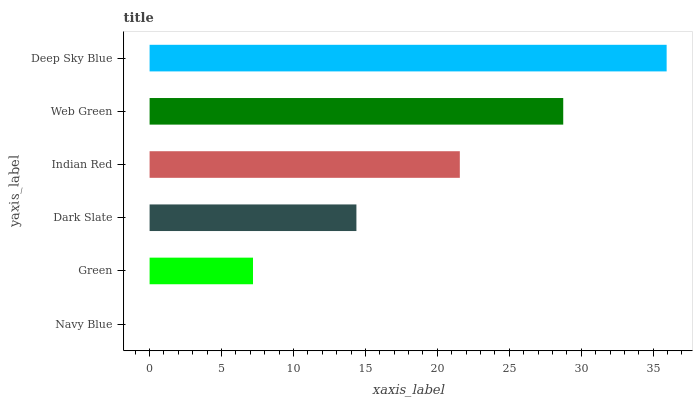Is Navy Blue the minimum?
Answer yes or no. Yes. Is Deep Sky Blue the maximum?
Answer yes or no. Yes. Is Green the minimum?
Answer yes or no. No. Is Green the maximum?
Answer yes or no. No. Is Green greater than Navy Blue?
Answer yes or no. Yes. Is Navy Blue less than Green?
Answer yes or no. Yes. Is Navy Blue greater than Green?
Answer yes or no. No. Is Green less than Navy Blue?
Answer yes or no. No. Is Indian Red the high median?
Answer yes or no. Yes. Is Dark Slate the low median?
Answer yes or no. Yes. Is Web Green the high median?
Answer yes or no. No. Is Web Green the low median?
Answer yes or no. No. 